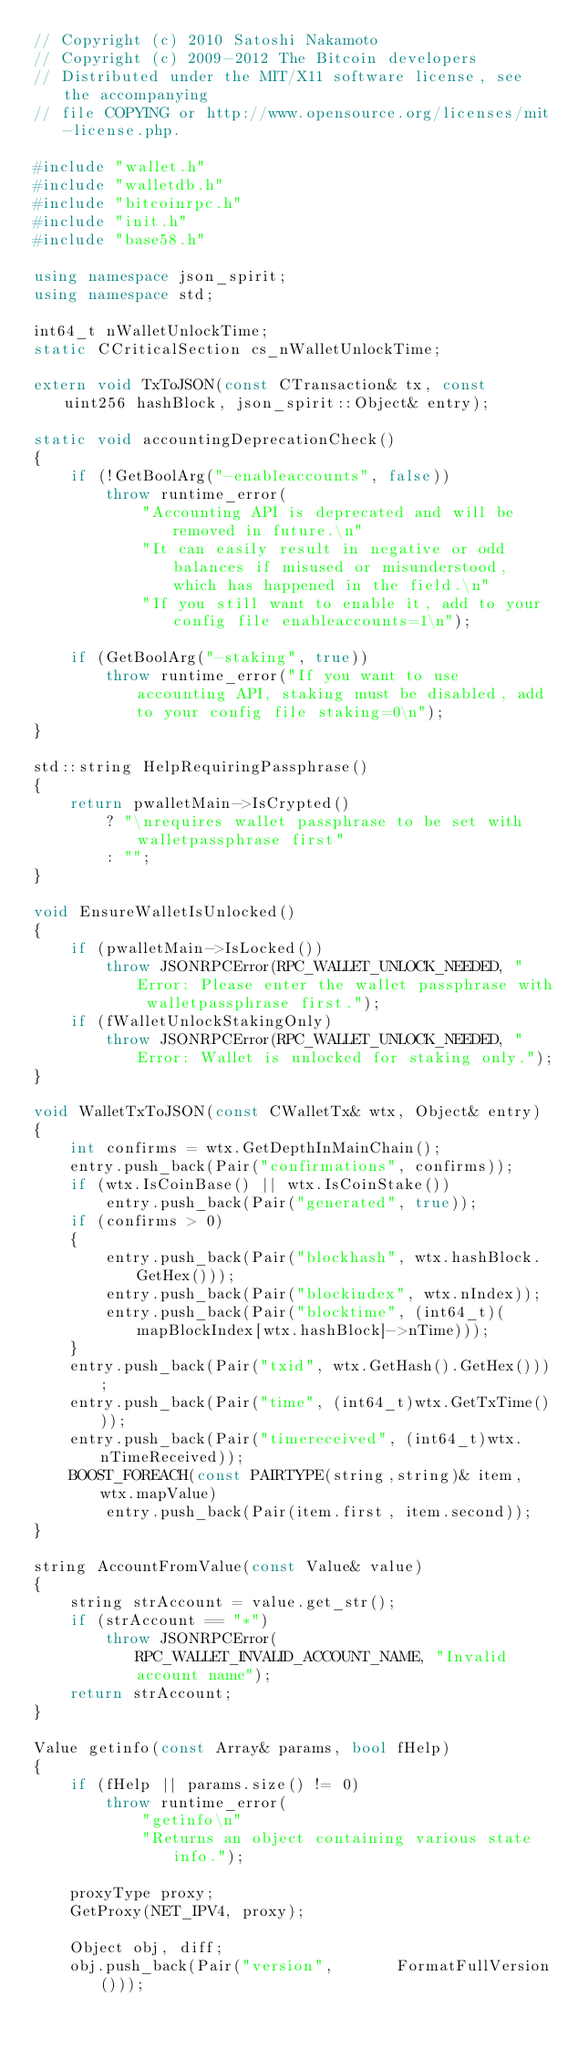<code> <loc_0><loc_0><loc_500><loc_500><_C++_>// Copyright (c) 2010 Satoshi Nakamoto
// Copyright (c) 2009-2012 The Bitcoin developers
// Distributed under the MIT/X11 software license, see the accompanying
// file COPYING or http://www.opensource.org/licenses/mit-license.php.

#include "wallet.h"
#include "walletdb.h"
#include "bitcoinrpc.h"
#include "init.h"
#include "base58.h"

using namespace json_spirit;
using namespace std;

int64_t nWalletUnlockTime;
static CCriticalSection cs_nWalletUnlockTime;

extern void TxToJSON(const CTransaction& tx, const uint256 hashBlock, json_spirit::Object& entry);

static void accountingDeprecationCheck()
{
    if (!GetBoolArg("-enableaccounts", false))
        throw runtime_error(
            "Accounting API is deprecated and will be removed in future.\n"
            "It can easily result in negative or odd balances if misused or misunderstood, which has happened in the field.\n"
            "If you still want to enable it, add to your config file enableaccounts=1\n");

    if (GetBoolArg("-staking", true))
        throw runtime_error("If you want to use accounting API, staking must be disabled, add to your config file staking=0\n");
}

std::string HelpRequiringPassphrase()
{
    return pwalletMain->IsCrypted()
        ? "\nrequires wallet passphrase to be set with walletpassphrase first"
        : "";
}

void EnsureWalletIsUnlocked()
{
    if (pwalletMain->IsLocked())
        throw JSONRPCError(RPC_WALLET_UNLOCK_NEEDED, "Error: Please enter the wallet passphrase with walletpassphrase first.");
    if (fWalletUnlockStakingOnly)
        throw JSONRPCError(RPC_WALLET_UNLOCK_NEEDED, "Error: Wallet is unlocked for staking only.");
}

void WalletTxToJSON(const CWalletTx& wtx, Object& entry)
{
    int confirms = wtx.GetDepthInMainChain();
    entry.push_back(Pair("confirmations", confirms));
    if (wtx.IsCoinBase() || wtx.IsCoinStake())
        entry.push_back(Pair("generated", true));
    if (confirms > 0)
    {
        entry.push_back(Pair("blockhash", wtx.hashBlock.GetHex()));
        entry.push_back(Pair("blockindex", wtx.nIndex));
        entry.push_back(Pair("blocktime", (int64_t)(mapBlockIndex[wtx.hashBlock]->nTime)));
    }
    entry.push_back(Pair("txid", wtx.GetHash().GetHex()));
    entry.push_back(Pair("time", (int64_t)wtx.GetTxTime()));
    entry.push_back(Pair("timereceived", (int64_t)wtx.nTimeReceived));
    BOOST_FOREACH(const PAIRTYPE(string,string)& item, wtx.mapValue)
        entry.push_back(Pair(item.first, item.second));
}

string AccountFromValue(const Value& value)
{
    string strAccount = value.get_str();
    if (strAccount == "*")
        throw JSONRPCError(RPC_WALLET_INVALID_ACCOUNT_NAME, "Invalid account name");
    return strAccount;
}

Value getinfo(const Array& params, bool fHelp)
{
    if (fHelp || params.size() != 0)
        throw runtime_error(
            "getinfo\n"
            "Returns an object containing various state info.");

    proxyType proxy;
    GetProxy(NET_IPV4, proxy);

    Object obj, diff;
    obj.push_back(Pair("version",       FormatFullVersion()));</code> 